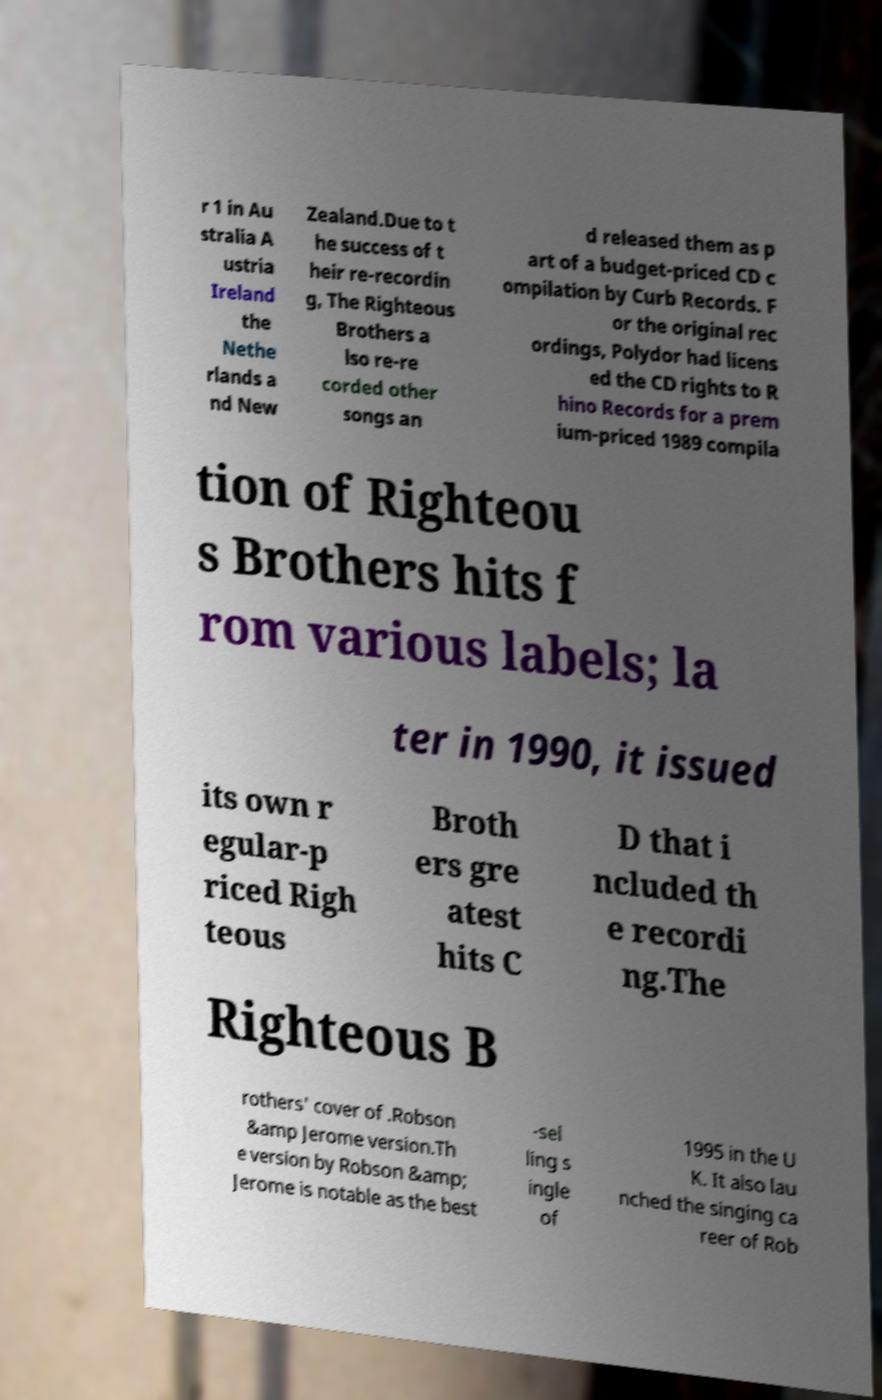Please identify and transcribe the text found in this image. r 1 in Au stralia A ustria Ireland the Nethe rlands a nd New Zealand.Due to t he success of t heir re-recordin g, The Righteous Brothers a lso re-re corded other songs an d released them as p art of a budget-priced CD c ompilation by Curb Records. F or the original rec ordings, Polydor had licens ed the CD rights to R hino Records for a prem ium-priced 1989 compila tion of Righteou s Brothers hits f rom various labels; la ter in 1990, it issued its own r egular-p riced Righ teous Broth ers gre atest hits C D that i ncluded th e recordi ng.The Righteous B rothers' cover of .Robson &amp Jerome version.Th e version by Robson &amp; Jerome is notable as the best -sel ling s ingle of 1995 in the U K. It also lau nched the singing ca reer of Rob 